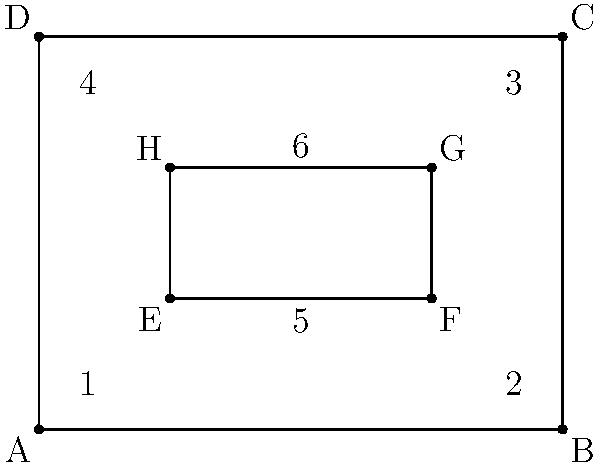In the diagram of a Saxon church tower's cross-section, which pairs of angles are congruent? Select all that apply:

a) 1 and 3
b) 2 and 4
c) 5 and 6
d) 1 and 2
e) 3 and 4 To identify congruent angles in this Saxon church tower cross-section, we need to analyze the geometric properties of the diagram:

1. The outer rectangle ABCD represents the tower's exterior walls.
2. The inner rectangle EFGH represents an architectural feature, possibly a window or opening.

Let's examine each pair of angles:

a) Angles 1 and 3:
   These are opposite angles in rectangle ABCD. In a rectangle, opposite angles are always congruent.

b) Angles 2 and 4:
   These are also opposite angles in rectangle ABCD, making them congruent.

c) Angles 5 and 6:
   These angles are formed by the sides of the inner rectangle EFGH. In a rectangle, all four angles are right angles (90°), making them congruent.

d) Angles 1 and 2:
   These are adjacent angles in rectangle ABCD. In a rectangle, adjacent angles are supplementary (sum to 180°) but not necessarily congruent.

e) Angles 3 and 4:
   Similar to angles 1 and 2, these are adjacent angles in rectangle ABCD and are not necessarily congruent.

Therefore, the congruent pairs of angles are:
- 1 and 3
- 2 and 4
- 5 and 6
Answer: a, b, c 